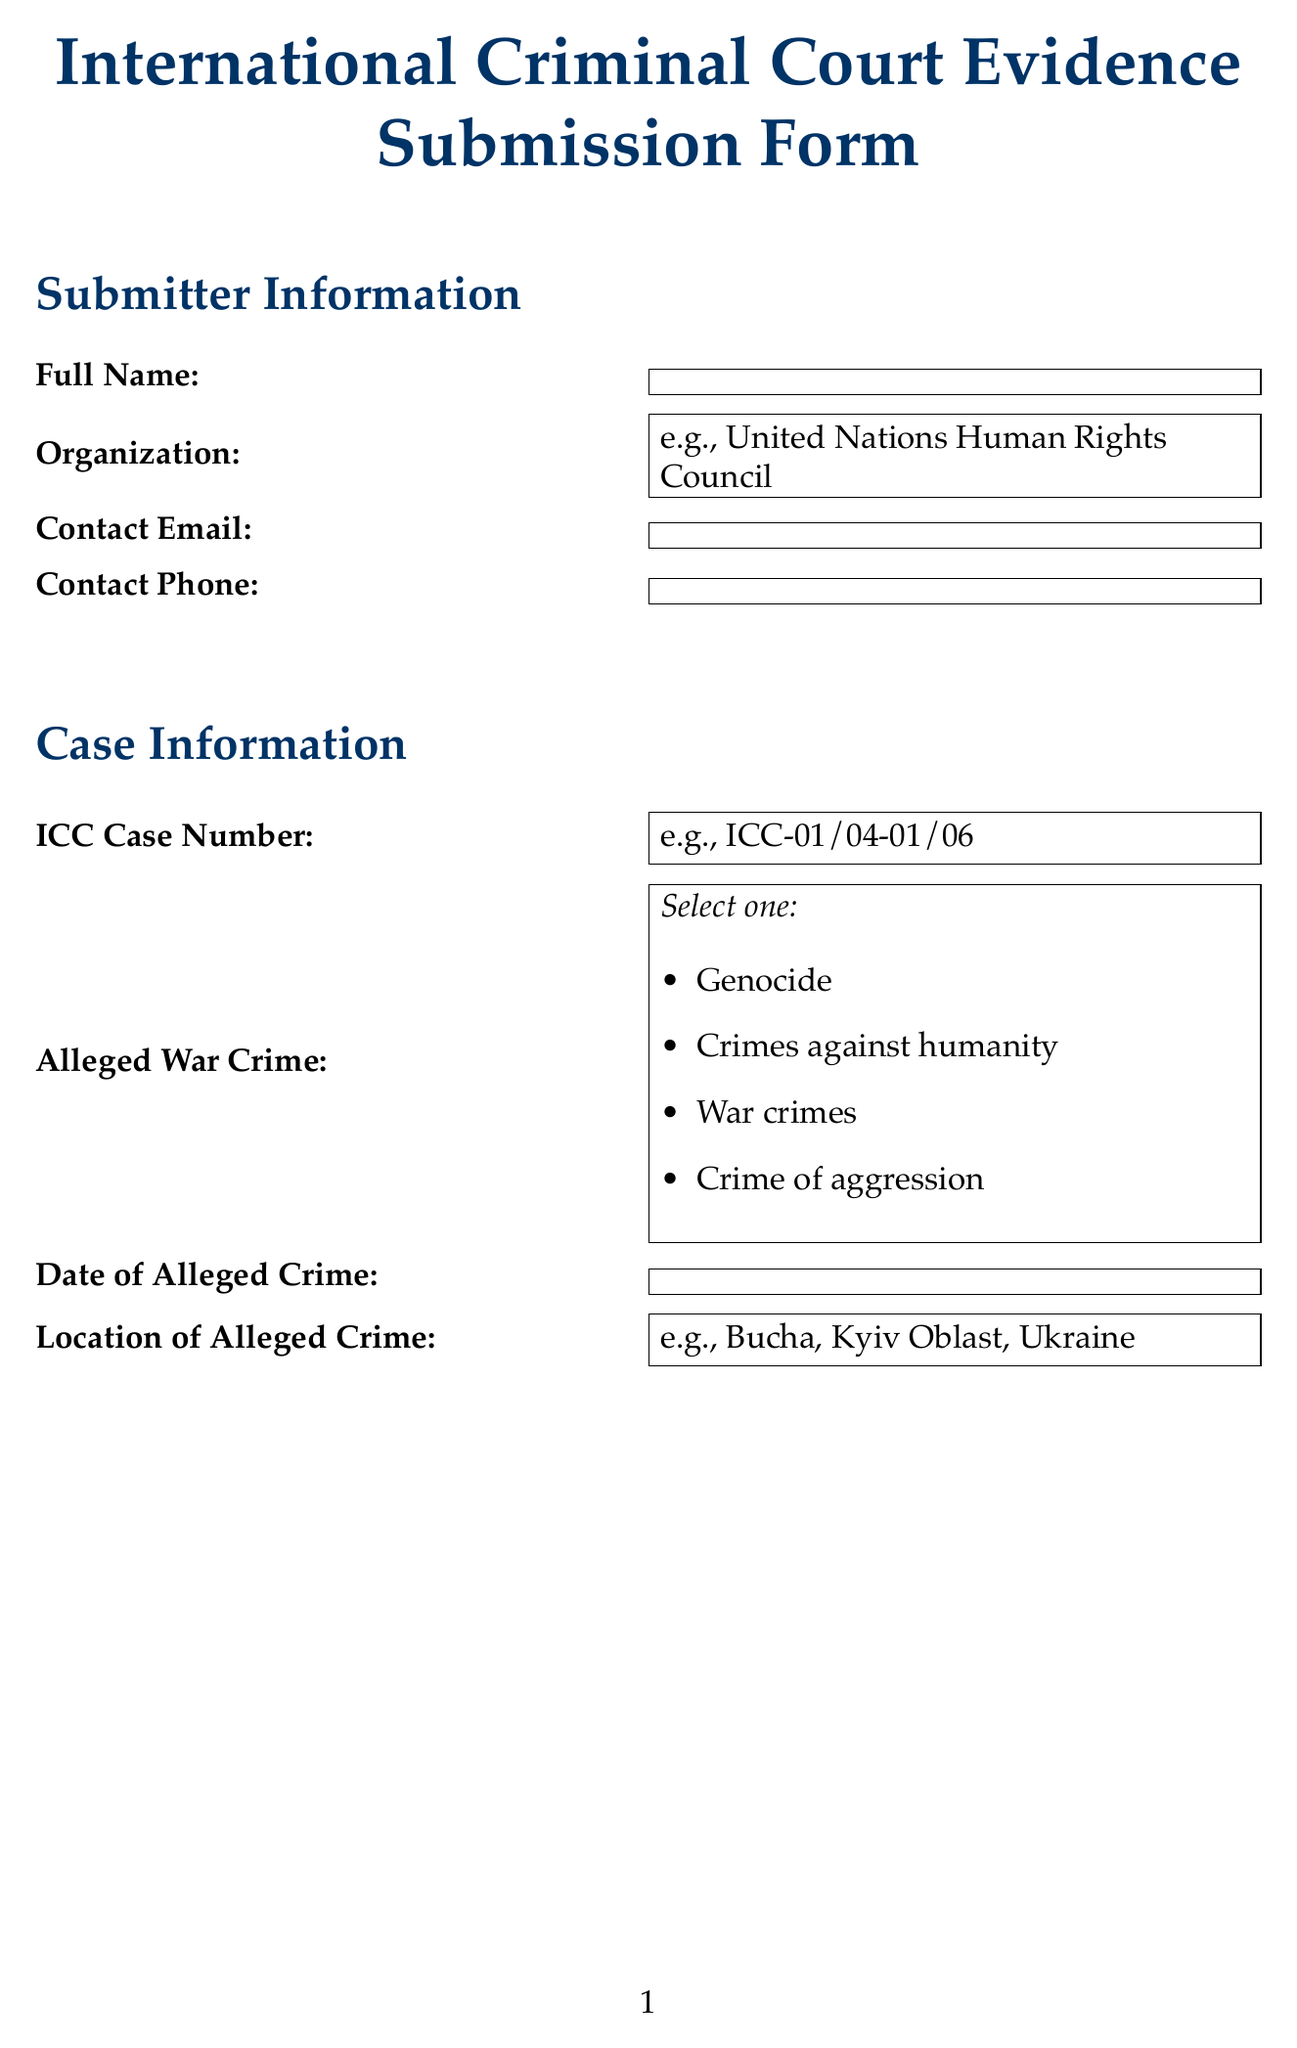what is the full name field type? The full name field type is specified as text in the document.
Answer: text what is the ICC Case Number example? The document provides an example of the ICC Case Number as "ICC-01/04-01/06".
Answer: ICC-01/04-01/06 which types of evidence can be selected? The document lists five types of evidence that can be selected in the dropdown: Documentary evidence, Physical evidence, Digital evidence, Testimonial evidence, and Forensic evidence.
Answer: Documentary evidence, Physical evidence, Digital evidence, Testimonial evidence, Forensic evidence what is the evidence collector name field type? The evidence collector name field type in the document is indicated as text.
Answer: text what is the potential impact on reconciliation process field type? The potential impact on reconciliation process field type is specified as a textarea in the document.
Answer: textarea what organization might verify authenticity? The example provided for the organization that might verify authenticity is the International Commission on Missing Persons (ICMP).
Answer: International Commission on Missing Persons (ICMP) how many custody transfers are listed? In the document, there are placeholders for multiple custody transfers, but no specific number is indicated as filled in.
Answer: Not specified what is the location of the alleged crime example? The document provides an example of the location of the alleged crime as "Bucha, Kyiv Oblast, Ukraine".
Answer: Bucha, Kyiv Oblast, Ukraine what is the date field type for the collection date? The collection date field type is categorized as date in the document.
Answer: date 